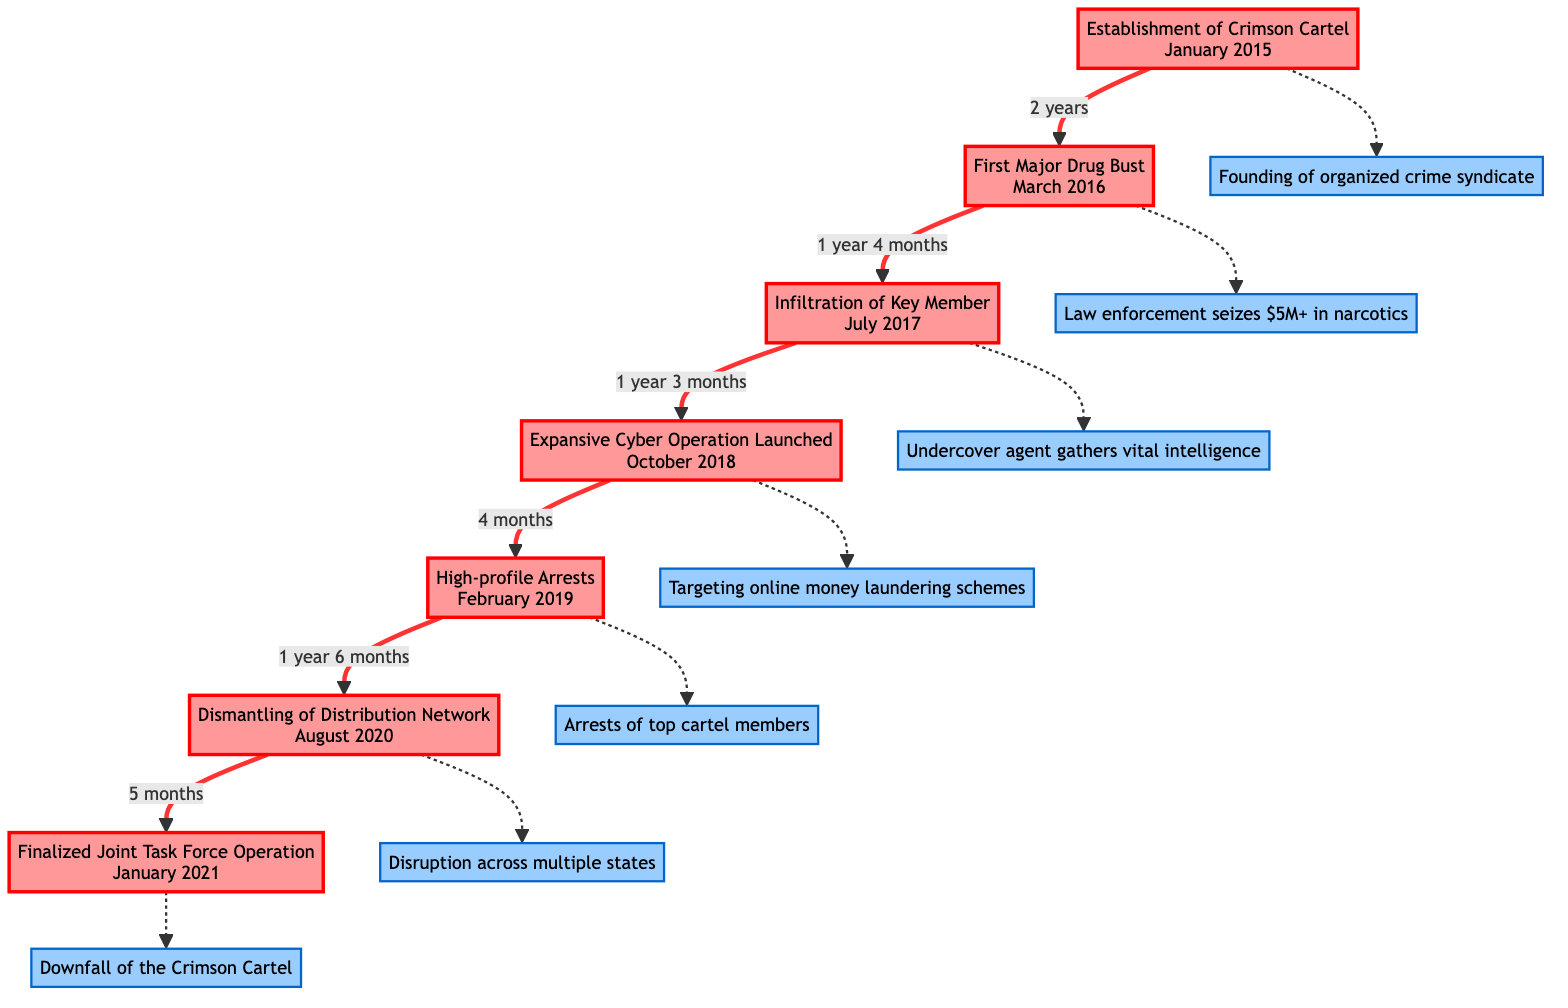What is the first event listed in the timeline? The first event listed is "Establishment of Crimson Cartel". This information is found at the top of the flowchart as the initial node.
Answer: Establishment of Crimson Cartel How many months elapsed between the establishment of the cartel and the first major drug bust? The time difference between January 2015 and March 2016 is 14 months. By examining the two nodes, we can calculate the duration.
Answer: 14 months What date did the infiltration of a key member occur? The infiltration of a key member took place in July 2017, as shown in the relevant node of the flowchart.
Answer: July 2017 What event directly follows the expansive cyber operation? The event that follows the expansive cyber operation is the "High-profile Arrests". This is determined by looking for the next node connected to the cyber operation.
Answer: High-profile Arrests Which event is directly connected to the dismantling of the distribution network? The event directly connected to the dismantling of the distribution network is the "Finalized Joint Task Force Operation", as indicated by the arrow linking these two nodes.
Answer: Finalized Joint Task Force Operation What type of crime did the Crimson Cartel specialize in? The Crimson Cartel specialized in drug trafficking and money laundering, which is explicitly stated in the description connected to the first node.
Answer: Drug trafficking and money laundering How long was it from the high-profile arrests to the dismantling of the distribution network? From February 2019 to August 2020, 1 year and 6 months passed. This can be calculated by assessing the timeframe outlined in the flowchart between these two events.
Answer: 1 year 6 months What significant action was taken in October 2018? In October 2018, an "Expansive Cyber Operation" was launched, which is specified in the corresponding node of the flowchart.
Answer: Expansive Cyber Operation How many key events are depicted in the flowchart? There are a total of 7 key events depicted in the timeline of the flowchart. This can be confirmed by counting the nodes representing individual events.
Answer: 7 